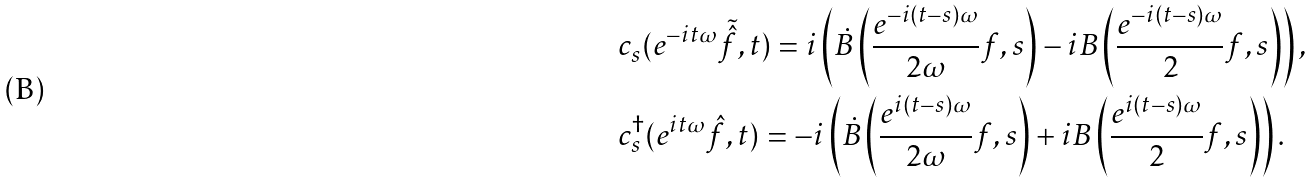<formula> <loc_0><loc_0><loc_500><loc_500>& c _ { s } ( e ^ { - i t \omega } \tilde { \hat { f } } , t ) = i \left ( \dot { B } \left ( \frac { e ^ { - i ( t - s ) \omega } } { 2 \omega } f , s \right ) - i B \left ( \frac { e ^ { - i ( t - s ) \omega } } { 2 } f , s \right ) \right ) , \\ & c _ { s } ^ { \dagger } ( e ^ { i t \omega } \hat { f } , t ) = - i \left ( \dot { B } \left ( \frac { e ^ { i ( t - s ) \omega } } { 2 \omega } f , s \right ) + i B \left ( \frac { e ^ { i ( t - s ) \omega } } { 2 } f , s \right ) \right ) .</formula> 